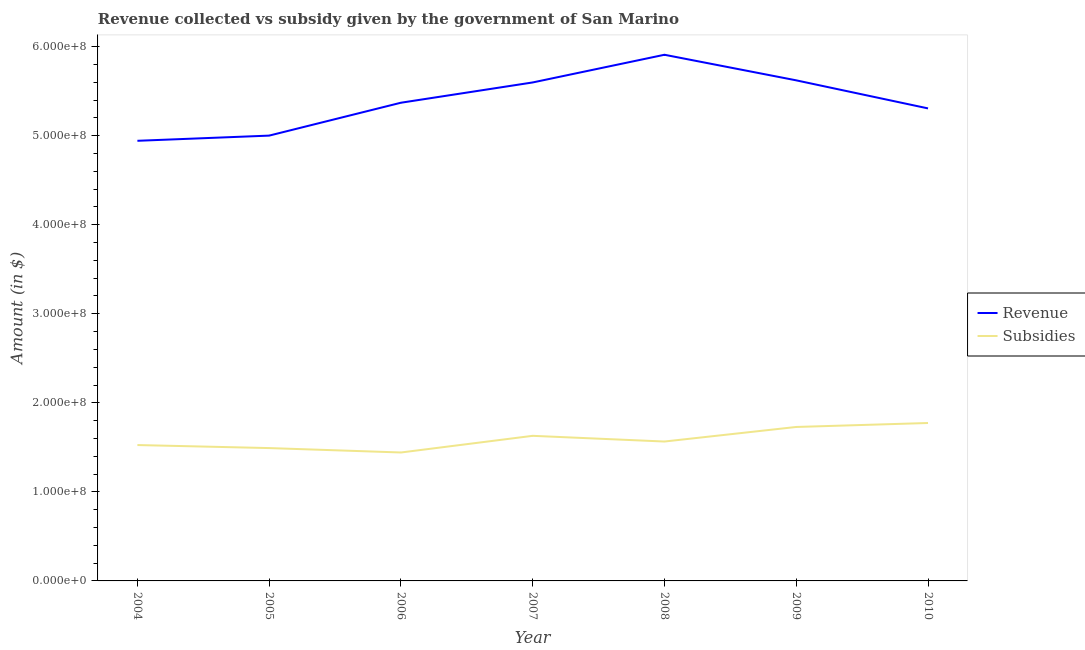What is the amount of revenue collected in 2009?
Provide a short and direct response. 5.62e+08. Across all years, what is the maximum amount of subsidies given?
Your answer should be very brief. 1.77e+08. Across all years, what is the minimum amount of revenue collected?
Offer a terse response. 4.94e+08. In which year was the amount of revenue collected maximum?
Provide a short and direct response. 2008. In which year was the amount of revenue collected minimum?
Provide a short and direct response. 2004. What is the total amount of revenue collected in the graph?
Ensure brevity in your answer.  3.78e+09. What is the difference between the amount of revenue collected in 2006 and that in 2010?
Your response must be concise. 6.37e+06. What is the difference between the amount of subsidies given in 2005 and the amount of revenue collected in 2006?
Provide a short and direct response. -3.88e+08. What is the average amount of revenue collected per year?
Your answer should be compact. 5.39e+08. In the year 2004, what is the difference between the amount of subsidies given and amount of revenue collected?
Make the answer very short. -3.42e+08. In how many years, is the amount of revenue collected greater than 280000000 $?
Ensure brevity in your answer.  7. What is the ratio of the amount of revenue collected in 2004 to that in 2010?
Provide a succinct answer. 0.93. Is the amount of subsidies given in 2004 less than that in 2005?
Keep it short and to the point. No. Is the difference between the amount of subsidies given in 2005 and 2010 greater than the difference between the amount of revenue collected in 2005 and 2010?
Keep it short and to the point. Yes. What is the difference between the highest and the second highest amount of subsidies given?
Your answer should be very brief. 4.45e+06. What is the difference between the highest and the lowest amount of revenue collected?
Make the answer very short. 9.66e+07. In how many years, is the amount of revenue collected greater than the average amount of revenue collected taken over all years?
Give a very brief answer. 3. Is the sum of the amount of revenue collected in 2004 and 2007 greater than the maximum amount of subsidies given across all years?
Your response must be concise. Yes. Does the amount of subsidies given monotonically increase over the years?
Keep it short and to the point. No. Is the amount of subsidies given strictly less than the amount of revenue collected over the years?
Your response must be concise. Yes. How many years are there in the graph?
Your answer should be compact. 7. Are the values on the major ticks of Y-axis written in scientific E-notation?
Your answer should be compact. Yes. Does the graph contain grids?
Provide a succinct answer. No. Where does the legend appear in the graph?
Your response must be concise. Center right. How are the legend labels stacked?
Your answer should be very brief. Vertical. What is the title of the graph?
Your response must be concise. Revenue collected vs subsidy given by the government of San Marino. Does "Travel services" appear as one of the legend labels in the graph?
Provide a short and direct response. No. What is the label or title of the Y-axis?
Keep it short and to the point. Amount (in $). What is the Amount (in $) in Revenue in 2004?
Offer a terse response. 4.94e+08. What is the Amount (in $) of Subsidies in 2004?
Provide a short and direct response. 1.53e+08. What is the Amount (in $) of Revenue in 2005?
Provide a succinct answer. 5.00e+08. What is the Amount (in $) of Subsidies in 2005?
Keep it short and to the point. 1.49e+08. What is the Amount (in $) in Revenue in 2006?
Provide a succinct answer. 5.37e+08. What is the Amount (in $) of Subsidies in 2006?
Offer a very short reply. 1.44e+08. What is the Amount (in $) of Revenue in 2007?
Offer a terse response. 5.60e+08. What is the Amount (in $) in Subsidies in 2007?
Ensure brevity in your answer.  1.63e+08. What is the Amount (in $) of Revenue in 2008?
Make the answer very short. 5.91e+08. What is the Amount (in $) in Subsidies in 2008?
Your answer should be very brief. 1.57e+08. What is the Amount (in $) in Revenue in 2009?
Offer a very short reply. 5.62e+08. What is the Amount (in $) of Subsidies in 2009?
Provide a short and direct response. 1.73e+08. What is the Amount (in $) of Revenue in 2010?
Offer a very short reply. 5.31e+08. What is the Amount (in $) of Subsidies in 2010?
Your response must be concise. 1.77e+08. Across all years, what is the maximum Amount (in $) of Revenue?
Provide a succinct answer. 5.91e+08. Across all years, what is the maximum Amount (in $) of Subsidies?
Offer a terse response. 1.77e+08. Across all years, what is the minimum Amount (in $) in Revenue?
Your answer should be very brief. 4.94e+08. Across all years, what is the minimum Amount (in $) of Subsidies?
Your response must be concise. 1.44e+08. What is the total Amount (in $) of Revenue in the graph?
Offer a very short reply. 3.78e+09. What is the total Amount (in $) in Subsidies in the graph?
Your response must be concise. 1.12e+09. What is the difference between the Amount (in $) of Revenue in 2004 and that in 2005?
Your answer should be compact. -5.82e+06. What is the difference between the Amount (in $) of Subsidies in 2004 and that in 2005?
Give a very brief answer. 3.40e+06. What is the difference between the Amount (in $) in Revenue in 2004 and that in 2006?
Your response must be concise. -4.28e+07. What is the difference between the Amount (in $) in Subsidies in 2004 and that in 2006?
Provide a succinct answer. 8.35e+06. What is the difference between the Amount (in $) in Revenue in 2004 and that in 2007?
Provide a short and direct response. -6.55e+07. What is the difference between the Amount (in $) of Subsidies in 2004 and that in 2007?
Your answer should be compact. -1.04e+07. What is the difference between the Amount (in $) in Revenue in 2004 and that in 2008?
Make the answer very short. -9.66e+07. What is the difference between the Amount (in $) in Subsidies in 2004 and that in 2008?
Provide a short and direct response. -3.96e+06. What is the difference between the Amount (in $) of Revenue in 2004 and that in 2009?
Give a very brief answer. -6.79e+07. What is the difference between the Amount (in $) of Subsidies in 2004 and that in 2009?
Your response must be concise. -2.03e+07. What is the difference between the Amount (in $) of Revenue in 2004 and that in 2010?
Provide a short and direct response. -3.64e+07. What is the difference between the Amount (in $) of Subsidies in 2004 and that in 2010?
Keep it short and to the point. -2.48e+07. What is the difference between the Amount (in $) in Revenue in 2005 and that in 2006?
Give a very brief answer. -3.69e+07. What is the difference between the Amount (in $) in Subsidies in 2005 and that in 2006?
Provide a succinct answer. 4.95e+06. What is the difference between the Amount (in $) of Revenue in 2005 and that in 2007?
Keep it short and to the point. -5.97e+07. What is the difference between the Amount (in $) in Subsidies in 2005 and that in 2007?
Offer a very short reply. -1.38e+07. What is the difference between the Amount (in $) of Revenue in 2005 and that in 2008?
Make the answer very short. -9.08e+07. What is the difference between the Amount (in $) in Subsidies in 2005 and that in 2008?
Give a very brief answer. -7.36e+06. What is the difference between the Amount (in $) in Revenue in 2005 and that in 2009?
Your answer should be very brief. -6.21e+07. What is the difference between the Amount (in $) of Subsidies in 2005 and that in 2009?
Provide a short and direct response. -2.37e+07. What is the difference between the Amount (in $) in Revenue in 2005 and that in 2010?
Your response must be concise. -3.06e+07. What is the difference between the Amount (in $) in Subsidies in 2005 and that in 2010?
Your answer should be compact. -2.82e+07. What is the difference between the Amount (in $) in Revenue in 2006 and that in 2007?
Ensure brevity in your answer.  -2.28e+07. What is the difference between the Amount (in $) of Subsidies in 2006 and that in 2007?
Your response must be concise. -1.87e+07. What is the difference between the Amount (in $) in Revenue in 2006 and that in 2008?
Ensure brevity in your answer.  -5.39e+07. What is the difference between the Amount (in $) of Subsidies in 2006 and that in 2008?
Ensure brevity in your answer.  -1.23e+07. What is the difference between the Amount (in $) of Revenue in 2006 and that in 2009?
Keep it short and to the point. -2.51e+07. What is the difference between the Amount (in $) of Subsidies in 2006 and that in 2009?
Ensure brevity in your answer.  -2.87e+07. What is the difference between the Amount (in $) of Revenue in 2006 and that in 2010?
Your response must be concise. 6.37e+06. What is the difference between the Amount (in $) of Subsidies in 2006 and that in 2010?
Give a very brief answer. -3.31e+07. What is the difference between the Amount (in $) of Revenue in 2007 and that in 2008?
Ensure brevity in your answer.  -3.11e+07. What is the difference between the Amount (in $) of Subsidies in 2007 and that in 2008?
Your answer should be very brief. 6.40e+06. What is the difference between the Amount (in $) in Revenue in 2007 and that in 2009?
Ensure brevity in your answer.  -2.35e+06. What is the difference between the Amount (in $) of Subsidies in 2007 and that in 2009?
Provide a short and direct response. -9.95e+06. What is the difference between the Amount (in $) in Revenue in 2007 and that in 2010?
Offer a very short reply. 2.91e+07. What is the difference between the Amount (in $) in Subsidies in 2007 and that in 2010?
Provide a short and direct response. -1.44e+07. What is the difference between the Amount (in $) in Revenue in 2008 and that in 2009?
Offer a very short reply. 2.87e+07. What is the difference between the Amount (in $) of Subsidies in 2008 and that in 2009?
Make the answer very short. -1.64e+07. What is the difference between the Amount (in $) of Revenue in 2008 and that in 2010?
Ensure brevity in your answer.  6.02e+07. What is the difference between the Amount (in $) of Subsidies in 2008 and that in 2010?
Ensure brevity in your answer.  -2.08e+07. What is the difference between the Amount (in $) of Revenue in 2009 and that in 2010?
Ensure brevity in your answer.  3.15e+07. What is the difference between the Amount (in $) in Subsidies in 2009 and that in 2010?
Your answer should be very brief. -4.45e+06. What is the difference between the Amount (in $) in Revenue in 2004 and the Amount (in $) in Subsidies in 2005?
Provide a short and direct response. 3.45e+08. What is the difference between the Amount (in $) of Revenue in 2004 and the Amount (in $) of Subsidies in 2006?
Offer a very short reply. 3.50e+08. What is the difference between the Amount (in $) of Revenue in 2004 and the Amount (in $) of Subsidies in 2007?
Provide a short and direct response. 3.31e+08. What is the difference between the Amount (in $) in Revenue in 2004 and the Amount (in $) in Subsidies in 2008?
Make the answer very short. 3.38e+08. What is the difference between the Amount (in $) of Revenue in 2004 and the Amount (in $) of Subsidies in 2009?
Provide a short and direct response. 3.21e+08. What is the difference between the Amount (in $) in Revenue in 2004 and the Amount (in $) in Subsidies in 2010?
Provide a short and direct response. 3.17e+08. What is the difference between the Amount (in $) of Revenue in 2005 and the Amount (in $) of Subsidies in 2006?
Offer a terse response. 3.56e+08. What is the difference between the Amount (in $) in Revenue in 2005 and the Amount (in $) in Subsidies in 2007?
Provide a succinct answer. 3.37e+08. What is the difference between the Amount (in $) in Revenue in 2005 and the Amount (in $) in Subsidies in 2008?
Offer a very short reply. 3.44e+08. What is the difference between the Amount (in $) of Revenue in 2005 and the Amount (in $) of Subsidies in 2009?
Provide a short and direct response. 3.27e+08. What is the difference between the Amount (in $) in Revenue in 2005 and the Amount (in $) in Subsidies in 2010?
Your answer should be very brief. 3.23e+08. What is the difference between the Amount (in $) in Revenue in 2006 and the Amount (in $) in Subsidies in 2007?
Make the answer very short. 3.74e+08. What is the difference between the Amount (in $) of Revenue in 2006 and the Amount (in $) of Subsidies in 2008?
Ensure brevity in your answer.  3.80e+08. What is the difference between the Amount (in $) of Revenue in 2006 and the Amount (in $) of Subsidies in 2009?
Your response must be concise. 3.64e+08. What is the difference between the Amount (in $) in Revenue in 2006 and the Amount (in $) in Subsidies in 2010?
Offer a terse response. 3.60e+08. What is the difference between the Amount (in $) of Revenue in 2007 and the Amount (in $) of Subsidies in 2008?
Make the answer very short. 4.03e+08. What is the difference between the Amount (in $) of Revenue in 2007 and the Amount (in $) of Subsidies in 2009?
Offer a terse response. 3.87e+08. What is the difference between the Amount (in $) in Revenue in 2007 and the Amount (in $) in Subsidies in 2010?
Your answer should be compact. 3.82e+08. What is the difference between the Amount (in $) in Revenue in 2008 and the Amount (in $) in Subsidies in 2009?
Give a very brief answer. 4.18e+08. What is the difference between the Amount (in $) in Revenue in 2008 and the Amount (in $) in Subsidies in 2010?
Your answer should be very brief. 4.14e+08. What is the difference between the Amount (in $) in Revenue in 2009 and the Amount (in $) in Subsidies in 2010?
Keep it short and to the point. 3.85e+08. What is the average Amount (in $) of Revenue per year?
Provide a short and direct response. 5.39e+08. What is the average Amount (in $) of Subsidies per year?
Make the answer very short. 1.59e+08. In the year 2004, what is the difference between the Amount (in $) of Revenue and Amount (in $) of Subsidies?
Provide a short and direct response. 3.42e+08. In the year 2005, what is the difference between the Amount (in $) in Revenue and Amount (in $) in Subsidies?
Your answer should be very brief. 3.51e+08. In the year 2006, what is the difference between the Amount (in $) of Revenue and Amount (in $) of Subsidies?
Offer a very short reply. 3.93e+08. In the year 2007, what is the difference between the Amount (in $) of Revenue and Amount (in $) of Subsidies?
Provide a short and direct response. 3.97e+08. In the year 2008, what is the difference between the Amount (in $) of Revenue and Amount (in $) of Subsidies?
Your answer should be very brief. 4.34e+08. In the year 2009, what is the difference between the Amount (in $) in Revenue and Amount (in $) in Subsidies?
Your answer should be compact. 3.89e+08. In the year 2010, what is the difference between the Amount (in $) in Revenue and Amount (in $) in Subsidies?
Make the answer very short. 3.53e+08. What is the ratio of the Amount (in $) in Revenue in 2004 to that in 2005?
Provide a succinct answer. 0.99. What is the ratio of the Amount (in $) of Subsidies in 2004 to that in 2005?
Offer a terse response. 1.02. What is the ratio of the Amount (in $) of Revenue in 2004 to that in 2006?
Make the answer very short. 0.92. What is the ratio of the Amount (in $) in Subsidies in 2004 to that in 2006?
Your answer should be compact. 1.06. What is the ratio of the Amount (in $) of Revenue in 2004 to that in 2007?
Give a very brief answer. 0.88. What is the ratio of the Amount (in $) of Subsidies in 2004 to that in 2007?
Ensure brevity in your answer.  0.94. What is the ratio of the Amount (in $) in Revenue in 2004 to that in 2008?
Ensure brevity in your answer.  0.84. What is the ratio of the Amount (in $) of Subsidies in 2004 to that in 2008?
Your answer should be compact. 0.97. What is the ratio of the Amount (in $) in Revenue in 2004 to that in 2009?
Keep it short and to the point. 0.88. What is the ratio of the Amount (in $) in Subsidies in 2004 to that in 2009?
Offer a very short reply. 0.88. What is the ratio of the Amount (in $) in Revenue in 2004 to that in 2010?
Make the answer very short. 0.93. What is the ratio of the Amount (in $) of Subsidies in 2004 to that in 2010?
Keep it short and to the point. 0.86. What is the ratio of the Amount (in $) of Revenue in 2005 to that in 2006?
Your answer should be compact. 0.93. What is the ratio of the Amount (in $) in Subsidies in 2005 to that in 2006?
Give a very brief answer. 1.03. What is the ratio of the Amount (in $) of Revenue in 2005 to that in 2007?
Your answer should be very brief. 0.89. What is the ratio of the Amount (in $) in Subsidies in 2005 to that in 2007?
Keep it short and to the point. 0.92. What is the ratio of the Amount (in $) of Revenue in 2005 to that in 2008?
Provide a succinct answer. 0.85. What is the ratio of the Amount (in $) of Subsidies in 2005 to that in 2008?
Provide a succinct answer. 0.95. What is the ratio of the Amount (in $) of Revenue in 2005 to that in 2009?
Make the answer very short. 0.89. What is the ratio of the Amount (in $) in Subsidies in 2005 to that in 2009?
Keep it short and to the point. 0.86. What is the ratio of the Amount (in $) of Revenue in 2005 to that in 2010?
Your answer should be very brief. 0.94. What is the ratio of the Amount (in $) of Subsidies in 2005 to that in 2010?
Your answer should be very brief. 0.84. What is the ratio of the Amount (in $) of Revenue in 2006 to that in 2007?
Offer a terse response. 0.96. What is the ratio of the Amount (in $) of Subsidies in 2006 to that in 2007?
Keep it short and to the point. 0.89. What is the ratio of the Amount (in $) of Revenue in 2006 to that in 2008?
Your answer should be very brief. 0.91. What is the ratio of the Amount (in $) in Subsidies in 2006 to that in 2008?
Give a very brief answer. 0.92. What is the ratio of the Amount (in $) in Revenue in 2006 to that in 2009?
Offer a terse response. 0.96. What is the ratio of the Amount (in $) in Subsidies in 2006 to that in 2009?
Give a very brief answer. 0.83. What is the ratio of the Amount (in $) of Subsidies in 2006 to that in 2010?
Provide a succinct answer. 0.81. What is the ratio of the Amount (in $) of Revenue in 2007 to that in 2008?
Ensure brevity in your answer.  0.95. What is the ratio of the Amount (in $) of Subsidies in 2007 to that in 2008?
Your answer should be compact. 1.04. What is the ratio of the Amount (in $) of Revenue in 2007 to that in 2009?
Your answer should be very brief. 1. What is the ratio of the Amount (in $) of Subsidies in 2007 to that in 2009?
Keep it short and to the point. 0.94. What is the ratio of the Amount (in $) in Revenue in 2007 to that in 2010?
Your response must be concise. 1.05. What is the ratio of the Amount (in $) in Subsidies in 2007 to that in 2010?
Provide a short and direct response. 0.92. What is the ratio of the Amount (in $) in Revenue in 2008 to that in 2009?
Your answer should be very brief. 1.05. What is the ratio of the Amount (in $) in Subsidies in 2008 to that in 2009?
Your answer should be very brief. 0.91. What is the ratio of the Amount (in $) in Revenue in 2008 to that in 2010?
Provide a short and direct response. 1.11. What is the ratio of the Amount (in $) in Subsidies in 2008 to that in 2010?
Make the answer very short. 0.88. What is the ratio of the Amount (in $) of Revenue in 2009 to that in 2010?
Provide a succinct answer. 1.06. What is the ratio of the Amount (in $) in Subsidies in 2009 to that in 2010?
Your answer should be compact. 0.97. What is the difference between the highest and the second highest Amount (in $) of Revenue?
Ensure brevity in your answer.  2.87e+07. What is the difference between the highest and the second highest Amount (in $) in Subsidies?
Make the answer very short. 4.45e+06. What is the difference between the highest and the lowest Amount (in $) in Revenue?
Your response must be concise. 9.66e+07. What is the difference between the highest and the lowest Amount (in $) of Subsidies?
Your answer should be compact. 3.31e+07. 